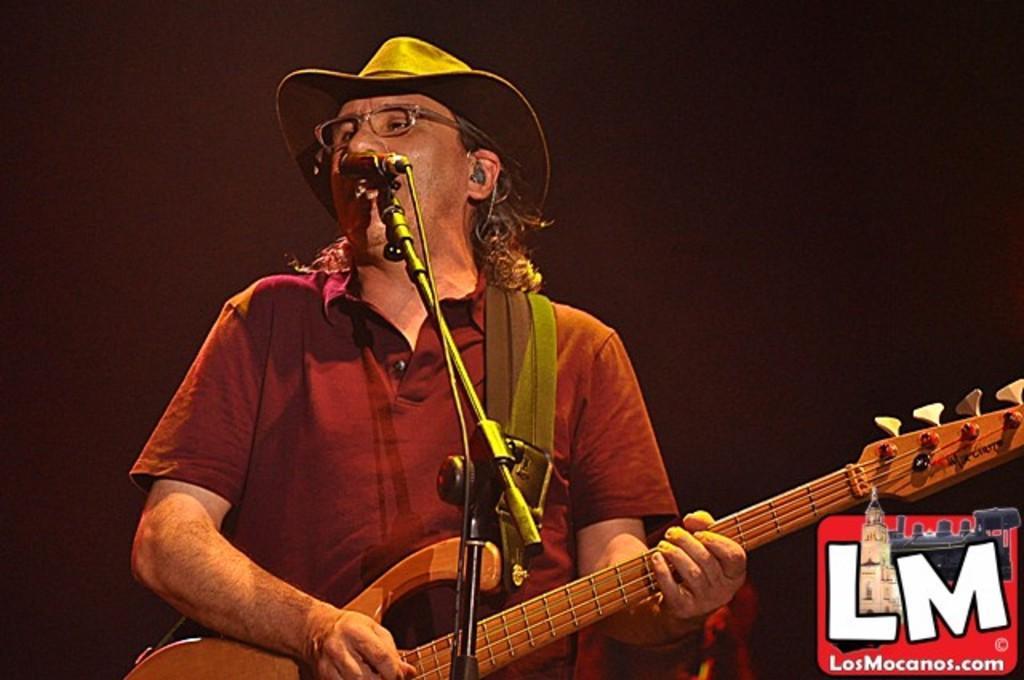How would you summarize this image in a sentence or two? This is the picture of a man with a hat and spectacle holding the guitar. In front of the man there is a microphone with stand. Background of the man is a black color on the image there is a watermark. 